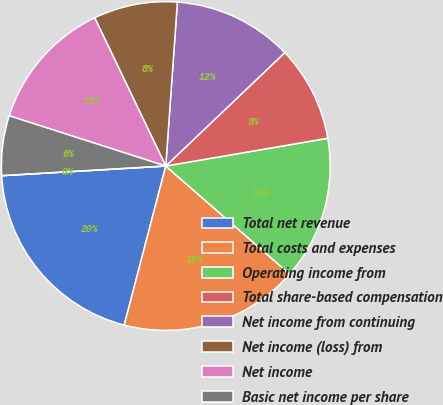<chart> <loc_0><loc_0><loc_500><loc_500><pie_chart><fcel>Total net revenue<fcel>Total costs and expenses<fcel>Operating income from<fcel>Total share-based compensation<fcel>Net income from continuing<fcel>Net income (loss) from<fcel>Net income<fcel>Basic net income per share<fcel>Basic net income (loss) per<nl><fcel>20.0%<fcel>17.65%<fcel>14.12%<fcel>9.41%<fcel>11.76%<fcel>8.24%<fcel>12.94%<fcel>5.88%<fcel>0.0%<nl></chart> 